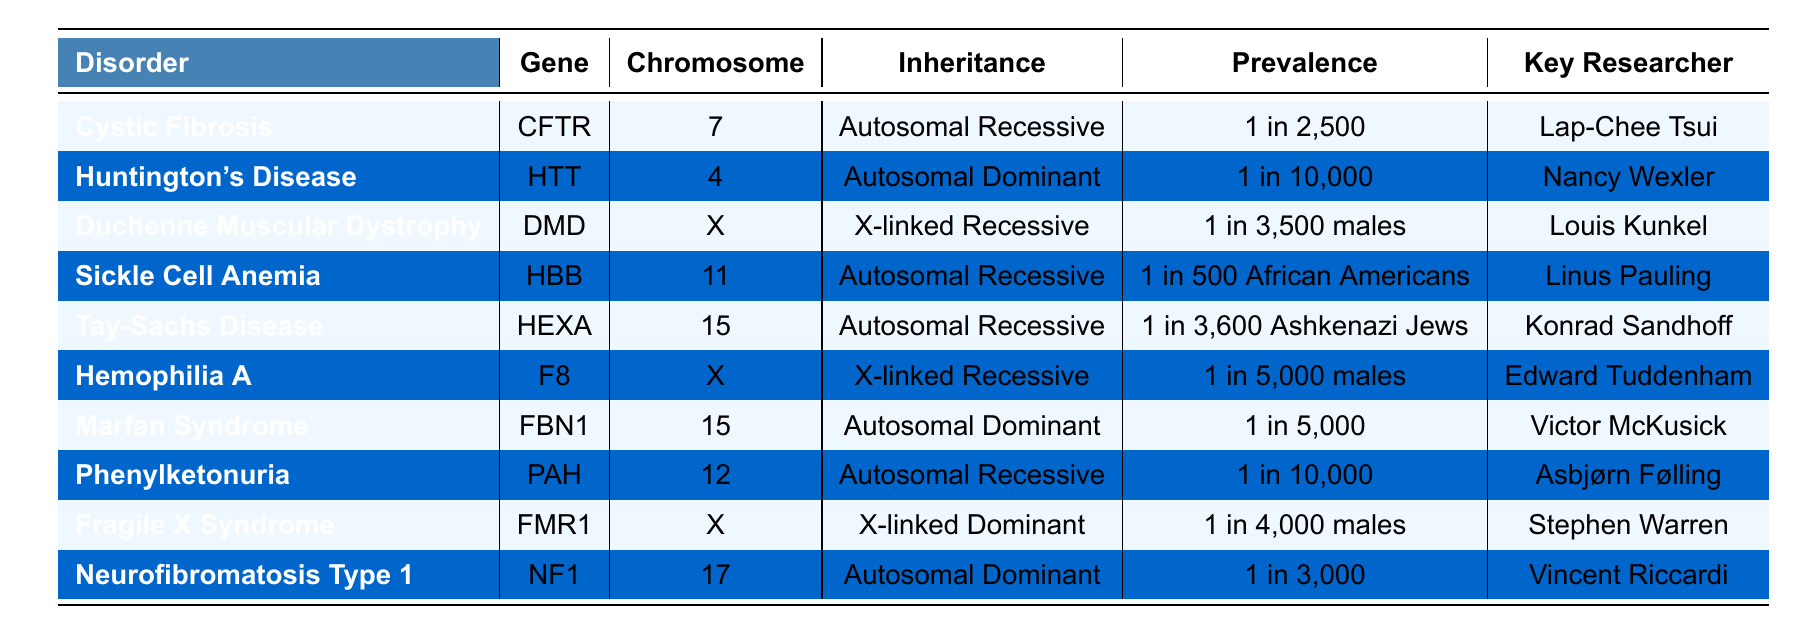What genetic disorder is associated with the gene CFTR? The table shows that the gene CFTR is associated with the disorder Cystic Fibrosis.
Answer: Cystic Fibrosis Which gene is located on chromosome 15 and associated with an Autosomal Dominant inheritance pattern? The table indicates that the gene FBN1 is located on chromosome 15 and is associated with an Autosomal Dominant inheritance pattern (Marfan Syndrome).
Answer: FBN1 How many disorders listed are associated with X-linked inheritance? The table shows that there are three disorders associated with X-linked inheritance: Duchenne Muscular Dystrophy, Hemophilia A, and Fragile X Syndrome. Counting these gives 3.
Answer: 3 Is the prevalence of Tay-Sachs Disease lower than that of Phenylketonuria? According to the table, Tay-Sachs Disease has a prevalence of 1 in 3,600 Ashkenazi Jews and Phenylketonuria has a prevalence of 1 in 10,000. Since 1 in 3,600 is numerically lower than 1 in 10,000, the statement is true.
Answer: Yes Which disorder has the highest prevalence and who is the key researcher associated with it? The highest prevalence is for Sickle Cell Anemia at 1 in 500 African Americans. The key researcher associated with Sickle Cell Anemia is Linus Pauling.
Answer: Sickle Cell Anemia; Linus Pauling What are the inheritance patterns of the disorders caused by the genes located on the X chromosome? The genes located on the X chromosome are DMD, F8, and FMR1. Their inheritance patterns are X-linked Recessive for DMD and F8, and X-linked Dominant for FMR1.
Answer: X-linked Recessive and X-linked Dominant How many disorders are inherited in an Autosomal Recessive pattern and which are they? There are five disorders inherited in an Autosomal Recessive pattern: Cystic Fibrosis, Sickle Cell Anemia, Tay-Sachs Disease, Phenylketonuria. Counting them gives 5.
Answer: 5; Cystic Fibrosis, Sickle Cell Anemia, Tay-Sachs Disease, Phenylketonuria Which researcher has been pivotal in the study of Huntington's Disease? The table lists Nancy Wexler as the key researcher associated with Huntington's Disease.
Answer: Nancy Wexler If we consider only Autosomal Dominant disorders, what is the prevalence range of these disorders listed in the table? The Autosomal Dominant disorders listed are Huntington's Disease, Marfan Syndrome, and Neurofibromatosis Type 1. Their prevalences are 1 in 10,000, 1 in 5,000, and 1 in 3,000 respectively. The range is from 1 in 10,000 to 1 in 3,000.
Answer: 1 in 10,000 to 1 in 3,000 Which disorder with a prevalence of 1 in 5,000 males is associated with an X-linked Recessive inheritance pattern? The table shows that Hemophilia A is associated with an X-linked Recessive inheritance pattern and has a prevalence of 1 in 5,000 males.
Answer: Hemophilia A 